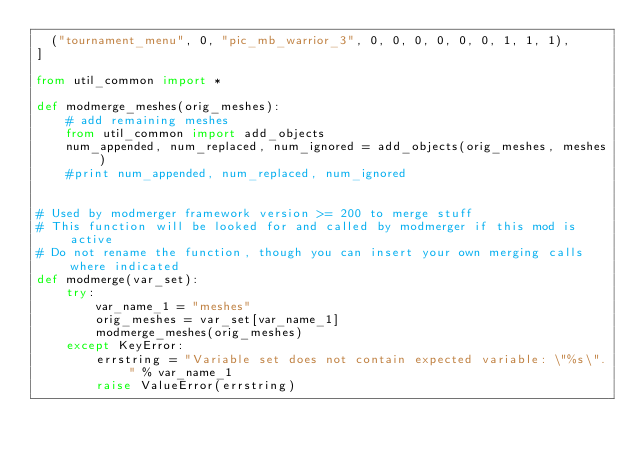<code> <loc_0><loc_0><loc_500><loc_500><_Python_>  ("tournament_menu", 0, "pic_mb_warrior_3", 0, 0, 0, 0, 0, 0, 1, 1, 1),
]

from util_common import *

def modmerge_meshes(orig_meshes):
    # add remaining meshes
    from util_common import add_objects
    num_appended, num_replaced, num_ignored = add_objects(orig_meshes, meshes)
    #print num_appended, num_replaced, num_ignored
	
	
# Used by modmerger framework version >= 200 to merge stuff
# This function will be looked for and called by modmerger if this mod is active
# Do not rename the function, though you can insert your own merging calls where indicated
def modmerge(var_set):
    try:
        var_name_1 = "meshes"
        orig_meshes = var_set[var_name_1]
        modmerge_meshes(orig_meshes)
    except KeyError:
        errstring = "Variable set does not contain expected variable: \"%s\"." % var_name_1
        raise ValueError(errstring)</code> 